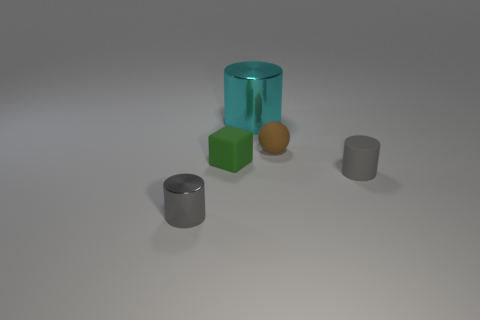Is there any other thing that is the same size as the cyan object?
Your answer should be very brief. No. Are there more gray objects on the left side of the big cyan shiny cylinder than gray shiny objects that are behind the green object?
Your answer should be very brief. Yes. Is the color of the small matte thing in front of the tiny green thing the same as the small metallic cylinder?
Your answer should be very brief. Yes. Is there any other thing of the same color as the tiny shiny cylinder?
Provide a short and direct response. Yes. Is the number of metallic objects that are in front of the big cyan object greater than the number of tiny cyan matte objects?
Ensure brevity in your answer.  Yes. Is the size of the cyan cylinder the same as the brown object?
Offer a terse response. No. There is a cyan thing that is the same shape as the gray metallic object; what is its material?
Make the answer very short. Metal. Is there anything else that has the same material as the cyan cylinder?
Offer a very short reply. Yes. What number of brown things are either matte objects or big shiny objects?
Your answer should be compact. 1. What is the gray object right of the gray metallic cylinder made of?
Provide a short and direct response. Rubber. 